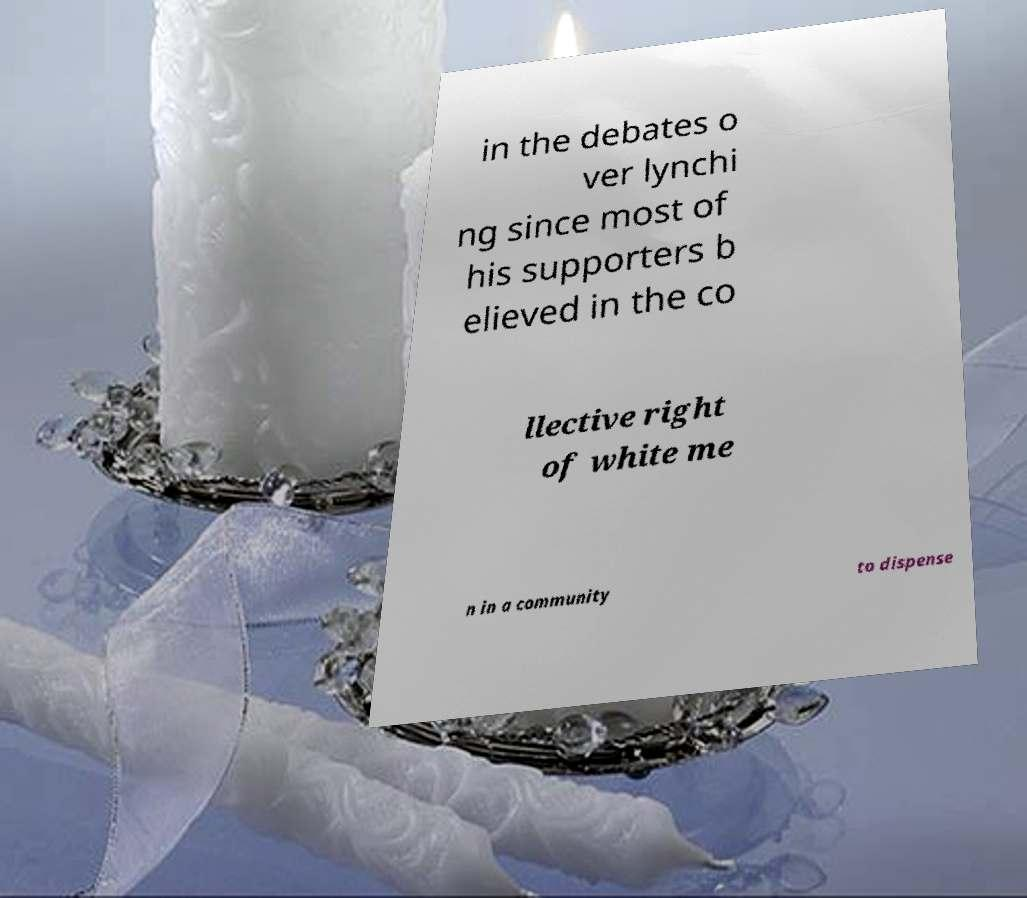Could you assist in decoding the text presented in this image and type it out clearly? in the debates o ver lynchi ng since most of his supporters b elieved in the co llective right of white me n in a community to dispense 